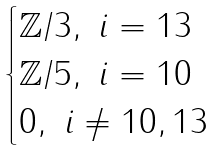Convert formula to latex. <formula><loc_0><loc_0><loc_500><loc_500>\begin{cases} \mathbb { Z } / 3 , \ i = 1 3 \\ \mathbb { Z } / 5 , \ i = 1 0 \\ 0 , \ i \neq 1 0 , 1 3 \end{cases}</formula> 